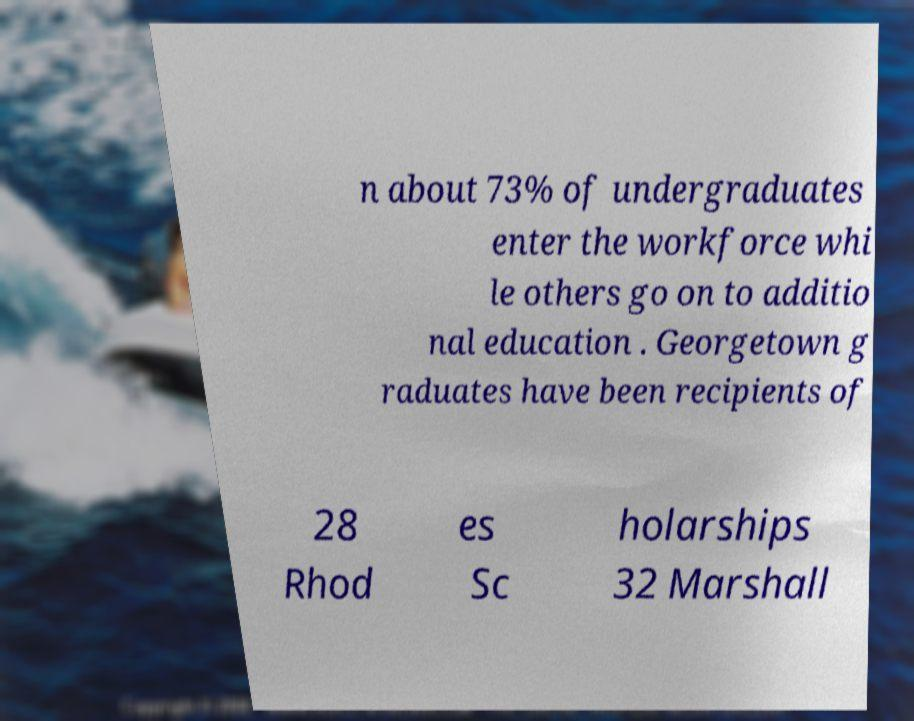For documentation purposes, I need the text within this image transcribed. Could you provide that? n about 73% of undergraduates enter the workforce whi le others go on to additio nal education . Georgetown g raduates have been recipients of 28 Rhod es Sc holarships 32 Marshall 